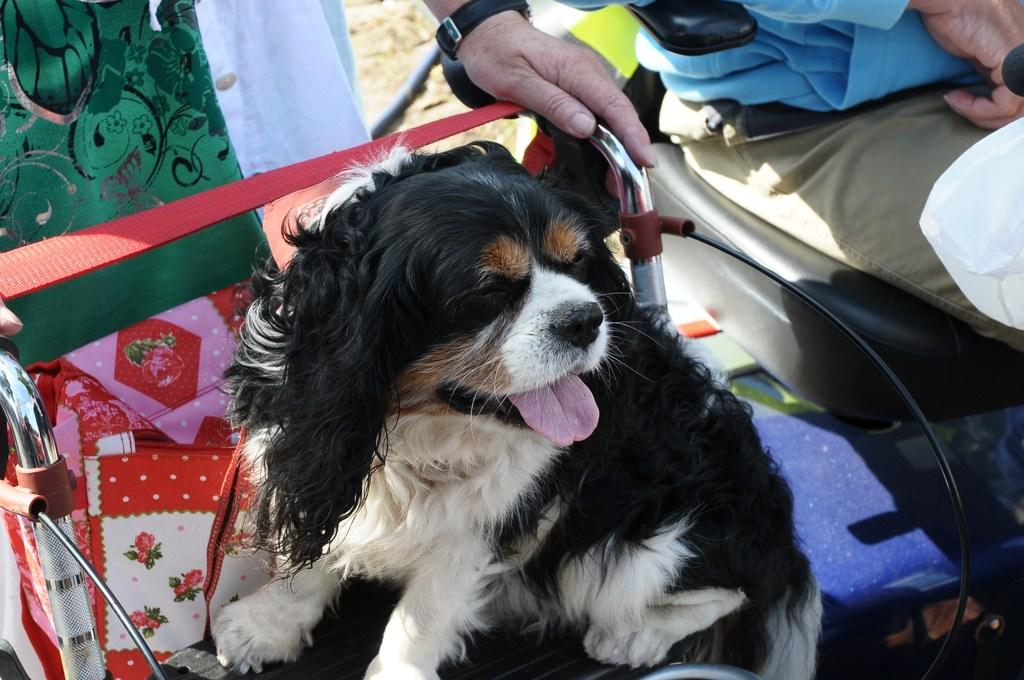What animal is present in the image? There is a dog in the image. What is the dog doing in the image? The dog is sitting on a chair. What else can be seen on the chair with the dog? There are items on the chair. Where is the person sitting in relation to the dog? The person is sitting on another chair on the right side of the dog. What type of bed can be seen in the image? There is no bed present in the image. 